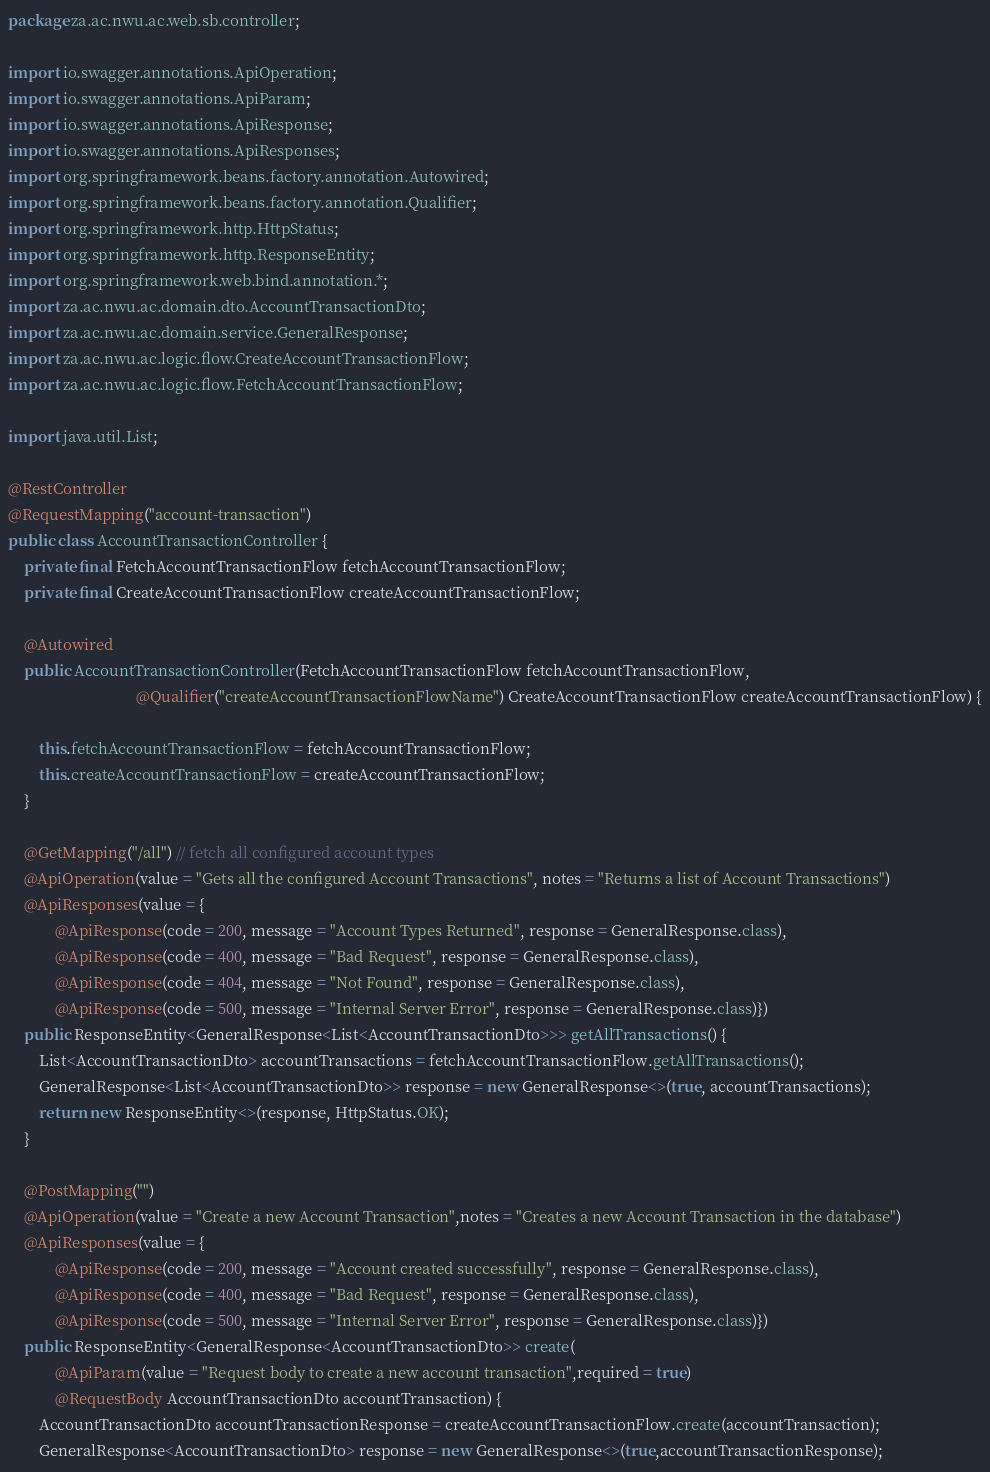Convert code to text. <code><loc_0><loc_0><loc_500><loc_500><_Java_>package za.ac.nwu.ac.web.sb.controller;

import io.swagger.annotations.ApiOperation;
import io.swagger.annotations.ApiParam;
import io.swagger.annotations.ApiResponse;
import io.swagger.annotations.ApiResponses;
import org.springframework.beans.factory.annotation.Autowired;
import org.springframework.beans.factory.annotation.Qualifier;
import org.springframework.http.HttpStatus;
import org.springframework.http.ResponseEntity;
import org.springframework.web.bind.annotation.*;
import za.ac.nwu.ac.domain.dto.AccountTransactionDto;
import za.ac.nwu.ac.domain.service.GeneralResponse;
import za.ac.nwu.ac.logic.flow.CreateAccountTransactionFlow;
import za.ac.nwu.ac.logic.flow.FetchAccountTransactionFlow;

import java.util.List;

@RestController
@RequestMapping("account-transaction")
public class AccountTransactionController {
    private final FetchAccountTransactionFlow fetchAccountTransactionFlow;
    private final CreateAccountTransactionFlow createAccountTransactionFlow;

    @Autowired
    public AccountTransactionController(FetchAccountTransactionFlow fetchAccountTransactionFlow,
                                 @Qualifier("createAccountTransactionFlowName") CreateAccountTransactionFlow createAccountTransactionFlow) {

        this.fetchAccountTransactionFlow = fetchAccountTransactionFlow;
        this.createAccountTransactionFlow = createAccountTransactionFlow;
    }

    @GetMapping("/all") // fetch all configured account types
    @ApiOperation(value = "Gets all the configured Account Transactions", notes = "Returns a list of Account Transactions")
    @ApiResponses(value = {
            @ApiResponse(code = 200, message = "Account Types Returned", response = GeneralResponse.class),
            @ApiResponse(code = 400, message = "Bad Request", response = GeneralResponse.class),
            @ApiResponse(code = 404, message = "Not Found", response = GeneralResponse.class),
            @ApiResponse(code = 500, message = "Internal Server Error", response = GeneralResponse.class)})
    public ResponseEntity<GeneralResponse<List<AccountTransactionDto>>> getAllTransactions() {
        List<AccountTransactionDto> accountTransactions = fetchAccountTransactionFlow.getAllTransactions();
        GeneralResponse<List<AccountTransactionDto>> response = new GeneralResponse<>(true, accountTransactions);
        return new ResponseEntity<>(response, HttpStatus.OK);
    }

    @PostMapping("")
    @ApiOperation(value = "Create a new Account Transaction",notes = "Creates a new Account Transaction in the database")
    @ApiResponses(value = {
            @ApiResponse(code = 200, message = "Account created successfully", response = GeneralResponse.class),
            @ApiResponse(code = 400, message = "Bad Request", response = GeneralResponse.class),
            @ApiResponse(code = 500, message = "Internal Server Error", response = GeneralResponse.class)})
    public ResponseEntity<GeneralResponse<AccountTransactionDto>> create(
            @ApiParam(value = "Request body to create a new account transaction",required = true)
            @RequestBody AccountTransactionDto accountTransaction) {
        AccountTransactionDto accountTransactionResponse = createAccountTransactionFlow.create(accountTransaction);
        GeneralResponse<AccountTransactionDto> response = new GeneralResponse<>(true,accountTransactionResponse);</code> 